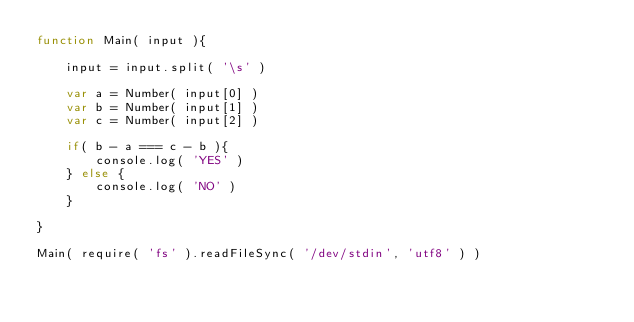Convert code to text. <code><loc_0><loc_0><loc_500><loc_500><_JavaScript_>function Main( input ){

    input = input.split( '\s' )

    var a = Number( input[0] )
    var b = Number( input[1] )
    var c = Number( input[2] )

    if( b - a === c - b ){
        console.log( 'YES' )
    } else {
        console.log( 'NO' )
    }

}

Main( require( 'fs' ).readFileSync( '/dev/stdin', 'utf8' ) )</code> 